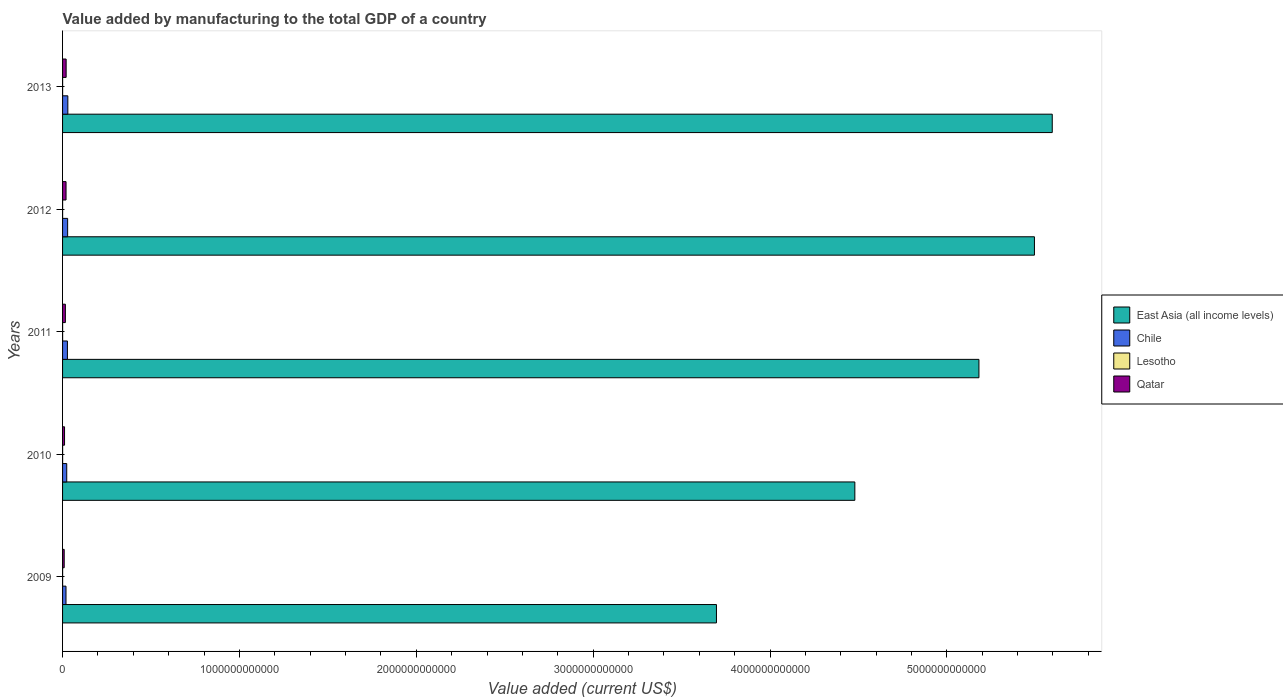How many different coloured bars are there?
Provide a succinct answer. 4. How many groups of bars are there?
Provide a short and direct response. 5. Are the number of bars per tick equal to the number of legend labels?
Your response must be concise. Yes. How many bars are there on the 4th tick from the top?
Provide a succinct answer. 4. What is the label of the 2nd group of bars from the top?
Give a very brief answer. 2012. What is the value added by manufacturing to the total GDP in East Asia (all income levels) in 2012?
Keep it short and to the point. 5.50e+12. Across all years, what is the maximum value added by manufacturing to the total GDP in Chile?
Your answer should be compact. 2.98e+1. Across all years, what is the minimum value added by manufacturing to the total GDP in Qatar?
Offer a very short reply. 9.22e+09. In which year was the value added by manufacturing to the total GDP in Qatar maximum?
Your answer should be compact. 2013. What is the total value added by manufacturing to the total GDP in Qatar in the graph?
Ensure brevity in your answer.  7.62e+1. What is the difference between the value added by manufacturing to the total GDP in Lesotho in 2010 and that in 2013?
Your answer should be very brief. 7.15e+07. What is the difference between the value added by manufacturing to the total GDP in Qatar in 2013 and the value added by manufacturing to the total GDP in Chile in 2012?
Offer a very short reply. -8.42e+09. What is the average value added by manufacturing to the total GDP in East Asia (all income levels) per year?
Provide a short and direct response. 4.89e+12. In the year 2013, what is the difference between the value added by manufacturing to the total GDP in Lesotho and value added by manufacturing to the total GDP in East Asia (all income levels)?
Your answer should be very brief. -5.60e+12. In how many years, is the value added by manufacturing to the total GDP in Qatar greater than 3800000000000 US$?
Provide a short and direct response. 0. What is the ratio of the value added by manufacturing to the total GDP in Qatar in 2009 to that in 2011?
Offer a terse response. 0.58. Is the value added by manufacturing to the total GDP in Chile in 2009 less than that in 2010?
Offer a very short reply. Yes. Is the difference between the value added by manufacturing to the total GDP in Lesotho in 2012 and 2013 greater than the difference between the value added by manufacturing to the total GDP in East Asia (all income levels) in 2012 and 2013?
Make the answer very short. Yes. What is the difference between the highest and the second highest value added by manufacturing to the total GDP in East Asia (all income levels)?
Keep it short and to the point. 1.01e+11. What is the difference between the highest and the lowest value added by manufacturing to the total GDP in Qatar?
Your answer should be compact. 1.10e+1. Is the sum of the value added by manufacturing to the total GDP in Chile in 2010 and 2013 greater than the maximum value added by manufacturing to the total GDP in East Asia (all income levels) across all years?
Your answer should be compact. No. What does the 1st bar from the top in 2011 represents?
Provide a succinct answer. Qatar. Is it the case that in every year, the sum of the value added by manufacturing to the total GDP in East Asia (all income levels) and value added by manufacturing to the total GDP in Lesotho is greater than the value added by manufacturing to the total GDP in Chile?
Provide a succinct answer. Yes. How many bars are there?
Your response must be concise. 20. How many years are there in the graph?
Provide a succinct answer. 5. What is the difference between two consecutive major ticks on the X-axis?
Offer a very short reply. 1.00e+12. Does the graph contain any zero values?
Make the answer very short. No. Where does the legend appear in the graph?
Your answer should be very brief. Center right. How many legend labels are there?
Your response must be concise. 4. How are the legend labels stacked?
Your answer should be very brief. Vertical. What is the title of the graph?
Your answer should be very brief. Value added by manufacturing to the total GDP of a country. Does "Greece" appear as one of the legend labels in the graph?
Offer a very short reply. No. What is the label or title of the X-axis?
Your answer should be compact. Value added (current US$). What is the label or title of the Y-axis?
Your answer should be compact. Years. What is the Value added (current US$) of East Asia (all income levels) in 2009?
Ensure brevity in your answer.  3.70e+12. What is the Value added (current US$) of Chile in 2009?
Your answer should be compact. 1.94e+1. What is the Value added (current US$) of Lesotho in 2009?
Provide a short and direct response. 2.50e+08. What is the Value added (current US$) in Qatar in 2009?
Your answer should be compact. 9.22e+09. What is the Value added (current US$) in East Asia (all income levels) in 2010?
Give a very brief answer. 4.48e+12. What is the Value added (current US$) of Chile in 2010?
Your response must be concise. 2.35e+1. What is the Value added (current US$) in Lesotho in 2010?
Keep it short and to the point. 2.76e+08. What is the Value added (current US$) of Qatar in 2010?
Offer a terse response. 1.12e+1. What is the Value added (current US$) in East Asia (all income levels) in 2011?
Keep it short and to the point. 5.18e+12. What is the Value added (current US$) in Chile in 2011?
Ensure brevity in your answer.  2.75e+1. What is the Value added (current US$) in Lesotho in 2011?
Your answer should be very brief. 2.64e+08. What is the Value added (current US$) of Qatar in 2011?
Make the answer very short. 1.59e+1. What is the Value added (current US$) of East Asia (all income levels) in 2012?
Give a very brief answer. 5.50e+12. What is the Value added (current US$) in Chile in 2012?
Make the answer very short. 2.87e+1. What is the Value added (current US$) in Lesotho in 2012?
Your answer should be compact. 2.41e+08. What is the Value added (current US$) in Qatar in 2012?
Provide a succinct answer. 1.97e+1. What is the Value added (current US$) of East Asia (all income levels) in 2013?
Keep it short and to the point. 5.60e+12. What is the Value added (current US$) of Chile in 2013?
Offer a terse response. 2.98e+1. What is the Value added (current US$) of Lesotho in 2013?
Offer a very short reply. 2.04e+08. What is the Value added (current US$) of Qatar in 2013?
Provide a short and direct response. 2.02e+1. Across all years, what is the maximum Value added (current US$) of East Asia (all income levels)?
Make the answer very short. 5.60e+12. Across all years, what is the maximum Value added (current US$) of Chile?
Your answer should be compact. 2.98e+1. Across all years, what is the maximum Value added (current US$) in Lesotho?
Give a very brief answer. 2.76e+08. Across all years, what is the maximum Value added (current US$) in Qatar?
Your answer should be very brief. 2.02e+1. Across all years, what is the minimum Value added (current US$) of East Asia (all income levels)?
Your answer should be compact. 3.70e+12. Across all years, what is the minimum Value added (current US$) of Chile?
Offer a terse response. 1.94e+1. Across all years, what is the minimum Value added (current US$) in Lesotho?
Provide a succinct answer. 2.04e+08. Across all years, what is the minimum Value added (current US$) in Qatar?
Your answer should be compact. 9.22e+09. What is the total Value added (current US$) of East Asia (all income levels) in the graph?
Provide a short and direct response. 2.44e+13. What is the total Value added (current US$) in Chile in the graph?
Offer a very short reply. 1.29e+11. What is the total Value added (current US$) in Lesotho in the graph?
Make the answer very short. 1.24e+09. What is the total Value added (current US$) in Qatar in the graph?
Keep it short and to the point. 7.62e+1. What is the difference between the Value added (current US$) in East Asia (all income levels) in 2009 and that in 2010?
Your answer should be very brief. -7.83e+11. What is the difference between the Value added (current US$) in Chile in 2009 and that in 2010?
Offer a very short reply. -4.11e+09. What is the difference between the Value added (current US$) in Lesotho in 2009 and that in 2010?
Your answer should be very brief. -2.59e+07. What is the difference between the Value added (current US$) of Qatar in 2009 and that in 2010?
Ensure brevity in your answer.  -2.00e+09. What is the difference between the Value added (current US$) of East Asia (all income levels) in 2009 and that in 2011?
Keep it short and to the point. -1.48e+12. What is the difference between the Value added (current US$) in Chile in 2009 and that in 2011?
Provide a succinct answer. -8.07e+09. What is the difference between the Value added (current US$) in Lesotho in 2009 and that in 2011?
Give a very brief answer. -1.40e+07. What is the difference between the Value added (current US$) in Qatar in 2009 and that in 2011?
Ensure brevity in your answer.  -6.66e+09. What is the difference between the Value added (current US$) in East Asia (all income levels) in 2009 and that in 2012?
Provide a short and direct response. -1.80e+12. What is the difference between the Value added (current US$) of Chile in 2009 and that in 2012?
Provide a succinct answer. -9.24e+09. What is the difference between the Value added (current US$) of Lesotho in 2009 and that in 2012?
Ensure brevity in your answer.  8.54e+06. What is the difference between the Value added (current US$) of Qatar in 2009 and that in 2012?
Offer a very short reply. -1.04e+1. What is the difference between the Value added (current US$) of East Asia (all income levels) in 2009 and that in 2013?
Your response must be concise. -1.90e+12. What is the difference between the Value added (current US$) in Chile in 2009 and that in 2013?
Ensure brevity in your answer.  -1.04e+1. What is the difference between the Value added (current US$) of Lesotho in 2009 and that in 2013?
Ensure brevity in your answer.  4.56e+07. What is the difference between the Value added (current US$) of Qatar in 2009 and that in 2013?
Your response must be concise. -1.10e+1. What is the difference between the Value added (current US$) in East Asia (all income levels) in 2010 and that in 2011?
Give a very brief answer. -7.02e+11. What is the difference between the Value added (current US$) in Chile in 2010 and that in 2011?
Offer a terse response. -3.96e+09. What is the difference between the Value added (current US$) of Lesotho in 2010 and that in 2011?
Keep it short and to the point. 1.19e+07. What is the difference between the Value added (current US$) in Qatar in 2010 and that in 2011?
Ensure brevity in your answer.  -4.66e+09. What is the difference between the Value added (current US$) of East Asia (all income levels) in 2010 and that in 2012?
Ensure brevity in your answer.  -1.02e+12. What is the difference between the Value added (current US$) of Chile in 2010 and that in 2012?
Offer a terse response. -5.13e+09. What is the difference between the Value added (current US$) in Lesotho in 2010 and that in 2012?
Your answer should be very brief. 3.45e+07. What is the difference between the Value added (current US$) of Qatar in 2010 and that in 2012?
Make the answer very short. -8.44e+09. What is the difference between the Value added (current US$) in East Asia (all income levels) in 2010 and that in 2013?
Make the answer very short. -1.12e+12. What is the difference between the Value added (current US$) of Chile in 2010 and that in 2013?
Your response must be concise. -6.30e+09. What is the difference between the Value added (current US$) of Lesotho in 2010 and that in 2013?
Your answer should be very brief. 7.15e+07. What is the difference between the Value added (current US$) of Qatar in 2010 and that in 2013?
Your response must be concise. -9.02e+09. What is the difference between the Value added (current US$) in East Asia (all income levels) in 2011 and that in 2012?
Provide a succinct answer. -3.14e+11. What is the difference between the Value added (current US$) of Chile in 2011 and that in 2012?
Provide a succinct answer. -1.17e+09. What is the difference between the Value added (current US$) of Lesotho in 2011 and that in 2012?
Keep it short and to the point. 2.26e+07. What is the difference between the Value added (current US$) in Qatar in 2011 and that in 2012?
Ensure brevity in your answer.  -3.77e+09. What is the difference between the Value added (current US$) in East Asia (all income levels) in 2011 and that in 2013?
Provide a short and direct response. -4.15e+11. What is the difference between the Value added (current US$) in Chile in 2011 and that in 2013?
Provide a succinct answer. -2.34e+09. What is the difference between the Value added (current US$) of Lesotho in 2011 and that in 2013?
Offer a terse response. 5.96e+07. What is the difference between the Value added (current US$) in Qatar in 2011 and that in 2013?
Make the answer very short. -4.35e+09. What is the difference between the Value added (current US$) in East Asia (all income levels) in 2012 and that in 2013?
Your answer should be very brief. -1.01e+11. What is the difference between the Value added (current US$) in Chile in 2012 and that in 2013?
Make the answer very short. -1.18e+09. What is the difference between the Value added (current US$) of Lesotho in 2012 and that in 2013?
Ensure brevity in your answer.  3.70e+07. What is the difference between the Value added (current US$) in Qatar in 2012 and that in 2013?
Your answer should be compact. -5.79e+08. What is the difference between the Value added (current US$) of East Asia (all income levels) in 2009 and the Value added (current US$) of Chile in 2010?
Provide a succinct answer. 3.67e+12. What is the difference between the Value added (current US$) of East Asia (all income levels) in 2009 and the Value added (current US$) of Lesotho in 2010?
Provide a short and direct response. 3.70e+12. What is the difference between the Value added (current US$) in East Asia (all income levels) in 2009 and the Value added (current US$) in Qatar in 2010?
Keep it short and to the point. 3.69e+12. What is the difference between the Value added (current US$) of Chile in 2009 and the Value added (current US$) of Lesotho in 2010?
Your response must be concise. 1.91e+1. What is the difference between the Value added (current US$) of Chile in 2009 and the Value added (current US$) of Qatar in 2010?
Your response must be concise. 8.20e+09. What is the difference between the Value added (current US$) in Lesotho in 2009 and the Value added (current US$) in Qatar in 2010?
Offer a terse response. -1.10e+1. What is the difference between the Value added (current US$) in East Asia (all income levels) in 2009 and the Value added (current US$) in Chile in 2011?
Give a very brief answer. 3.67e+12. What is the difference between the Value added (current US$) in East Asia (all income levels) in 2009 and the Value added (current US$) in Lesotho in 2011?
Keep it short and to the point. 3.70e+12. What is the difference between the Value added (current US$) of East Asia (all income levels) in 2009 and the Value added (current US$) of Qatar in 2011?
Make the answer very short. 3.68e+12. What is the difference between the Value added (current US$) of Chile in 2009 and the Value added (current US$) of Lesotho in 2011?
Offer a terse response. 1.92e+1. What is the difference between the Value added (current US$) of Chile in 2009 and the Value added (current US$) of Qatar in 2011?
Your response must be concise. 3.54e+09. What is the difference between the Value added (current US$) of Lesotho in 2009 and the Value added (current US$) of Qatar in 2011?
Make the answer very short. -1.56e+1. What is the difference between the Value added (current US$) in East Asia (all income levels) in 2009 and the Value added (current US$) in Chile in 2012?
Offer a very short reply. 3.67e+12. What is the difference between the Value added (current US$) of East Asia (all income levels) in 2009 and the Value added (current US$) of Lesotho in 2012?
Offer a very short reply. 3.70e+12. What is the difference between the Value added (current US$) of East Asia (all income levels) in 2009 and the Value added (current US$) of Qatar in 2012?
Offer a terse response. 3.68e+12. What is the difference between the Value added (current US$) in Chile in 2009 and the Value added (current US$) in Lesotho in 2012?
Ensure brevity in your answer.  1.92e+1. What is the difference between the Value added (current US$) in Chile in 2009 and the Value added (current US$) in Qatar in 2012?
Give a very brief answer. -2.33e+08. What is the difference between the Value added (current US$) in Lesotho in 2009 and the Value added (current US$) in Qatar in 2012?
Ensure brevity in your answer.  -1.94e+1. What is the difference between the Value added (current US$) of East Asia (all income levels) in 2009 and the Value added (current US$) of Chile in 2013?
Provide a succinct answer. 3.67e+12. What is the difference between the Value added (current US$) of East Asia (all income levels) in 2009 and the Value added (current US$) of Lesotho in 2013?
Give a very brief answer. 3.70e+12. What is the difference between the Value added (current US$) of East Asia (all income levels) in 2009 and the Value added (current US$) of Qatar in 2013?
Give a very brief answer. 3.68e+12. What is the difference between the Value added (current US$) in Chile in 2009 and the Value added (current US$) in Lesotho in 2013?
Make the answer very short. 1.92e+1. What is the difference between the Value added (current US$) of Chile in 2009 and the Value added (current US$) of Qatar in 2013?
Give a very brief answer. -8.12e+08. What is the difference between the Value added (current US$) in Lesotho in 2009 and the Value added (current US$) in Qatar in 2013?
Your answer should be compact. -2.00e+1. What is the difference between the Value added (current US$) in East Asia (all income levels) in 2010 and the Value added (current US$) in Chile in 2011?
Give a very brief answer. 4.45e+12. What is the difference between the Value added (current US$) in East Asia (all income levels) in 2010 and the Value added (current US$) in Lesotho in 2011?
Give a very brief answer. 4.48e+12. What is the difference between the Value added (current US$) of East Asia (all income levels) in 2010 and the Value added (current US$) of Qatar in 2011?
Provide a short and direct response. 4.46e+12. What is the difference between the Value added (current US$) of Chile in 2010 and the Value added (current US$) of Lesotho in 2011?
Provide a succinct answer. 2.33e+1. What is the difference between the Value added (current US$) of Chile in 2010 and the Value added (current US$) of Qatar in 2011?
Keep it short and to the point. 7.65e+09. What is the difference between the Value added (current US$) in Lesotho in 2010 and the Value added (current US$) in Qatar in 2011?
Offer a terse response. -1.56e+1. What is the difference between the Value added (current US$) in East Asia (all income levels) in 2010 and the Value added (current US$) in Chile in 2012?
Offer a very short reply. 4.45e+12. What is the difference between the Value added (current US$) in East Asia (all income levels) in 2010 and the Value added (current US$) in Lesotho in 2012?
Keep it short and to the point. 4.48e+12. What is the difference between the Value added (current US$) of East Asia (all income levels) in 2010 and the Value added (current US$) of Qatar in 2012?
Keep it short and to the point. 4.46e+12. What is the difference between the Value added (current US$) of Chile in 2010 and the Value added (current US$) of Lesotho in 2012?
Ensure brevity in your answer.  2.33e+1. What is the difference between the Value added (current US$) in Chile in 2010 and the Value added (current US$) in Qatar in 2012?
Provide a short and direct response. 3.87e+09. What is the difference between the Value added (current US$) in Lesotho in 2010 and the Value added (current US$) in Qatar in 2012?
Your response must be concise. -1.94e+1. What is the difference between the Value added (current US$) in East Asia (all income levels) in 2010 and the Value added (current US$) in Chile in 2013?
Ensure brevity in your answer.  4.45e+12. What is the difference between the Value added (current US$) of East Asia (all income levels) in 2010 and the Value added (current US$) of Lesotho in 2013?
Keep it short and to the point. 4.48e+12. What is the difference between the Value added (current US$) in East Asia (all income levels) in 2010 and the Value added (current US$) in Qatar in 2013?
Your answer should be very brief. 4.46e+12. What is the difference between the Value added (current US$) of Chile in 2010 and the Value added (current US$) of Lesotho in 2013?
Make the answer very short. 2.33e+1. What is the difference between the Value added (current US$) in Chile in 2010 and the Value added (current US$) in Qatar in 2013?
Provide a short and direct response. 3.30e+09. What is the difference between the Value added (current US$) in Lesotho in 2010 and the Value added (current US$) in Qatar in 2013?
Give a very brief answer. -2.00e+1. What is the difference between the Value added (current US$) in East Asia (all income levels) in 2011 and the Value added (current US$) in Chile in 2012?
Offer a terse response. 5.15e+12. What is the difference between the Value added (current US$) in East Asia (all income levels) in 2011 and the Value added (current US$) in Lesotho in 2012?
Your answer should be compact. 5.18e+12. What is the difference between the Value added (current US$) in East Asia (all income levels) in 2011 and the Value added (current US$) in Qatar in 2012?
Keep it short and to the point. 5.16e+12. What is the difference between the Value added (current US$) in Chile in 2011 and the Value added (current US$) in Lesotho in 2012?
Provide a short and direct response. 2.72e+1. What is the difference between the Value added (current US$) of Chile in 2011 and the Value added (current US$) of Qatar in 2012?
Your response must be concise. 7.83e+09. What is the difference between the Value added (current US$) of Lesotho in 2011 and the Value added (current US$) of Qatar in 2012?
Keep it short and to the point. -1.94e+1. What is the difference between the Value added (current US$) of East Asia (all income levels) in 2011 and the Value added (current US$) of Chile in 2013?
Make the answer very short. 5.15e+12. What is the difference between the Value added (current US$) in East Asia (all income levels) in 2011 and the Value added (current US$) in Lesotho in 2013?
Provide a succinct answer. 5.18e+12. What is the difference between the Value added (current US$) in East Asia (all income levels) in 2011 and the Value added (current US$) in Qatar in 2013?
Give a very brief answer. 5.16e+12. What is the difference between the Value added (current US$) in Chile in 2011 and the Value added (current US$) in Lesotho in 2013?
Give a very brief answer. 2.73e+1. What is the difference between the Value added (current US$) of Chile in 2011 and the Value added (current US$) of Qatar in 2013?
Make the answer very short. 7.26e+09. What is the difference between the Value added (current US$) of Lesotho in 2011 and the Value added (current US$) of Qatar in 2013?
Your answer should be compact. -2.00e+1. What is the difference between the Value added (current US$) of East Asia (all income levels) in 2012 and the Value added (current US$) of Chile in 2013?
Provide a short and direct response. 5.47e+12. What is the difference between the Value added (current US$) of East Asia (all income levels) in 2012 and the Value added (current US$) of Lesotho in 2013?
Give a very brief answer. 5.49e+12. What is the difference between the Value added (current US$) of East Asia (all income levels) in 2012 and the Value added (current US$) of Qatar in 2013?
Ensure brevity in your answer.  5.47e+12. What is the difference between the Value added (current US$) in Chile in 2012 and the Value added (current US$) in Lesotho in 2013?
Your response must be concise. 2.85e+1. What is the difference between the Value added (current US$) in Chile in 2012 and the Value added (current US$) in Qatar in 2013?
Ensure brevity in your answer.  8.42e+09. What is the difference between the Value added (current US$) in Lesotho in 2012 and the Value added (current US$) in Qatar in 2013?
Your response must be concise. -2.00e+1. What is the average Value added (current US$) in East Asia (all income levels) per year?
Provide a short and direct response. 4.89e+12. What is the average Value added (current US$) of Chile per year?
Make the answer very short. 2.58e+1. What is the average Value added (current US$) in Lesotho per year?
Provide a succinct answer. 2.47e+08. What is the average Value added (current US$) of Qatar per year?
Your answer should be compact. 1.52e+1. In the year 2009, what is the difference between the Value added (current US$) in East Asia (all income levels) and Value added (current US$) in Chile?
Keep it short and to the point. 3.68e+12. In the year 2009, what is the difference between the Value added (current US$) of East Asia (all income levels) and Value added (current US$) of Lesotho?
Provide a succinct answer. 3.70e+12. In the year 2009, what is the difference between the Value added (current US$) of East Asia (all income levels) and Value added (current US$) of Qatar?
Give a very brief answer. 3.69e+12. In the year 2009, what is the difference between the Value added (current US$) of Chile and Value added (current US$) of Lesotho?
Offer a very short reply. 1.92e+1. In the year 2009, what is the difference between the Value added (current US$) in Chile and Value added (current US$) in Qatar?
Your answer should be compact. 1.02e+1. In the year 2009, what is the difference between the Value added (current US$) in Lesotho and Value added (current US$) in Qatar?
Provide a short and direct response. -8.97e+09. In the year 2010, what is the difference between the Value added (current US$) of East Asia (all income levels) and Value added (current US$) of Chile?
Make the answer very short. 4.46e+12. In the year 2010, what is the difference between the Value added (current US$) of East Asia (all income levels) and Value added (current US$) of Lesotho?
Keep it short and to the point. 4.48e+12. In the year 2010, what is the difference between the Value added (current US$) of East Asia (all income levels) and Value added (current US$) of Qatar?
Ensure brevity in your answer.  4.47e+12. In the year 2010, what is the difference between the Value added (current US$) of Chile and Value added (current US$) of Lesotho?
Your response must be concise. 2.33e+1. In the year 2010, what is the difference between the Value added (current US$) in Chile and Value added (current US$) in Qatar?
Your answer should be very brief. 1.23e+1. In the year 2010, what is the difference between the Value added (current US$) of Lesotho and Value added (current US$) of Qatar?
Your answer should be very brief. -1.09e+1. In the year 2011, what is the difference between the Value added (current US$) of East Asia (all income levels) and Value added (current US$) of Chile?
Provide a succinct answer. 5.15e+12. In the year 2011, what is the difference between the Value added (current US$) in East Asia (all income levels) and Value added (current US$) in Lesotho?
Offer a very short reply. 5.18e+12. In the year 2011, what is the difference between the Value added (current US$) in East Asia (all income levels) and Value added (current US$) in Qatar?
Your response must be concise. 5.17e+12. In the year 2011, what is the difference between the Value added (current US$) in Chile and Value added (current US$) in Lesotho?
Keep it short and to the point. 2.72e+1. In the year 2011, what is the difference between the Value added (current US$) in Chile and Value added (current US$) in Qatar?
Your answer should be very brief. 1.16e+1. In the year 2011, what is the difference between the Value added (current US$) in Lesotho and Value added (current US$) in Qatar?
Give a very brief answer. -1.56e+1. In the year 2012, what is the difference between the Value added (current US$) in East Asia (all income levels) and Value added (current US$) in Chile?
Your answer should be compact. 5.47e+12. In the year 2012, what is the difference between the Value added (current US$) in East Asia (all income levels) and Value added (current US$) in Lesotho?
Provide a succinct answer. 5.49e+12. In the year 2012, what is the difference between the Value added (current US$) of East Asia (all income levels) and Value added (current US$) of Qatar?
Give a very brief answer. 5.48e+12. In the year 2012, what is the difference between the Value added (current US$) in Chile and Value added (current US$) in Lesotho?
Keep it short and to the point. 2.84e+1. In the year 2012, what is the difference between the Value added (current US$) in Chile and Value added (current US$) in Qatar?
Your answer should be compact. 9.00e+09. In the year 2012, what is the difference between the Value added (current US$) in Lesotho and Value added (current US$) in Qatar?
Provide a short and direct response. -1.94e+1. In the year 2013, what is the difference between the Value added (current US$) in East Asia (all income levels) and Value added (current US$) in Chile?
Keep it short and to the point. 5.57e+12. In the year 2013, what is the difference between the Value added (current US$) of East Asia (all income levels) and Value added (current US$) of Lesotho?
Provide a succinct answer. 5.60e+12. In the year 2013, what is the difference between the Value added (current US$) in East Asia (all income levels) and Value added (current US$) in Qatar?
Your answer should be very brief. 5.58e+12. In the year 2013, what is the difference between the Value added (current US$) of Chile and Value added (current US$) of Lesotho?
Provide a succinct answer. 2.96e+1. In the year 2013, what is the difference between the Value added (current US$) in Chile and Value added (current US$) in Qatar?
Your answer should be very brief. 9.60e+09. In the year 2013, what is the difference between the Value added (current US$) in Lesotho and Value added (current US$) in Qatar?
Ensure brevity in your answer.  -2.00e+1. What is the ratio of the Value added (current US$) in East Asia (all income levels) in 2009 to that in 2010?
Your response must be concise. 0.83. What is the ratio of the Value added (current US$) in Chile in 2009 to that in 2010?
Provide a short and direct response. 0.83. What is the ratio of the Value added (current US$) of Lesotho in 2009 to that in 2010?
Offer a very short reply. 0.91. What is the ratio of the Value added (current US$) of Qatar in 2009 to that in 2010?
Your answer should be very brief. 0.82. What is the ratio of the Value added (current US$) in East Asia (all income levels) in 2009 to that in 2011?
Give a very brief answer. 0.71. What is the ratio of the Value added (current US$) of Chile in 2009 to that in 2011?
Provide a succinct answer. 0.71. What is the ratio of the Value added (current US$) of Lesotho in 2009 to that in 2011?
Keep it short and to the point. 0.95. What is the ratio of the Value added (current US$) of Qatar in 2009 to that in 2011?
Make the answer very short. 0.58. What is the ratio of the Value added (current US$) in East Asia (all income levels) in 2009 to that in 2012?
Give a very brief answer. 0.67. What is the ratio of the Value added (current US$) in Chile in 2009 to that in 2012?
Offer a terse response. 0.68. What is the ratio of the Value added (current US$) of Lesotho in 2009 to that in 2012?
Your answer should be very brief. 1.04. What is the ratio of the Value added (current US$) in Qatar in 2009 to that in 2012?
Provide a short and direct response. 0.47. What is the ratio of the Value added (current US$) in East Asia (all income levels) in 2009 to that in 2013?
Provide a short and direct response. 0.66. What is the ratio of the Value added (current US$) in Chile in 2009 to that in 2013?
Your answer should be very brief. 0.65. What is the ratio of the Value added (current US$) of Lesotho in 2009 to that in 2013?
Ensure brevity in your answer.  1.22. What is the ratio of the Value added (current US$) of Qatar in 2009 to that in 2013?
Provide a short and direct response. 0.46. What is the ratio of the Value added (current US$) in East Asia (all income levels) in 2010 to that in 2011?
Provide a short and direct response. 0.86. What is the ratio of the Value added (current US$) of Chile in 2010 to that in 2011?
Keep it short and to the point. 0.86. What is the ratio of the Value added (current US$) of Lesotho in 2010 to that in 2011?
Make the answer very short. 1.05. What is the ratio of the Value added (current US$) of Qatar in 2010 to that in 2011?
Make the answer very short. 0.71. What is the ratio of the Value added (current US$) of East Asia (all income levels) in 2010 to that in 2012?
Ensure brevity in your answer.  0.82. What is the ratio of the Value added (current US$) of Chile in 2010 to that in 2012?
Provide a short and direct response. 0.82. What is the ratio of the Value added (current US$) in Lesotho in 2010 to that in 2012?
Your response must be concise. 1.14. What is the ratio of the Value added (current US$) in Qatar in 2010 to that in 2012?
Provide a short and direct response. 0.57. What is the ratio of the Value added (current US$) in East Asia (all income levels) in 2010 to that in 2013?
Your answer should be very brief. 0.8. What is the ratio of the Value added (current US$) in Chile in 2010 to that in 2013?
Keep it short and to the point. 0.79. What is the ratio of the Value added (current US$) in Lesotho in 2010 to that in 2013?
Provide a succinct answer. 1.35. What is the ratio of the Value added (current US$) of Qatar in 2010 to that in 2013?
Your answer should be very brief. 0.55. What is the ratio of the Value added (current US$) of East Asia (all income levels) in 2011 to that in 2012?
Give a very brief answer. 0.94. What is the ratio of the Value added (current US$) in Chile in 2011 to that in 2012?
Offer a terse response. 0.96. What is the ratio of the Value added (current US$) of Lesotho in 2011 to that in 2012?
Your response must be concise. 1.09. What is the ratio of the Value added (current US$) of Qatar in 2011 to that in 2012?
Provide a short and direct response. 0.81. What is the ratio of the Value added (current US$) of East Asia (all income levels) in 2011 to that in 2013?
Provide a succinct answer. 0.93. What is the ratio of the Value added (current US$) in Chile in 2011 to that in 2013?
Ensure brevity in your answer.  0.92. What is the ratio of the Value added (current US$) in Lesotho in 2011 to that in 2013?
Give a very brief answer. 1.29. What is the ratio of the Value added (current US$) of Qatar in 2011 to that in 2013?
Your response must be concise. 0.79. What is the ratio of the Value added (current US$) in East Asia (all income levels) in 2012 to that in 2013?
Your answer should be compact. 0.98. What is the ratio of the Value added (current US$) of Chile in 2012 to that in 2013?
Make the answer very short. 0.96. What is the ratio of the Value added (current US$) in Lesotho in 2012 to that in 2013?
Keep it short and to the point. 1.18. What is the ratio of the Value added (current US$) of Qatar in 2012 to that in 2013?
Ensure brevity in your answer.  0.97. What is the difference between the highest and the second highest Value added (current US$) of East Asia (all income levels)?
Provide a succinct answer. 1.01e+11. What is the difference between the highest and the second highest Value added (current US$) of Chile?
Provide a succinct answer. 1.18e+09. What is the difference between the highest and the second highest Value added (current US$) of Lesotho?
Your response must be concise. 1.19e+07. What is the difference between the highest and the second highest Value added (current US$) of Qatar?
Provide a short and direct response. 5.79e+08. What is the difference between the highest and the lowest Value added (current US$) of East Asia (all income levels)?
Provide a short and direct response. 1.90e+12. What is the difference between the highest and the lowest Value added (current US$) in Chile?
Provide a short and direct response. 1.04e+1. What is the difference between the highest and the lowest Value added (current US$) of Lesotho?
Your answer should be very brief. 7.15e+07. What is the difference between the highest and the lowest Value added (current US$) of Qatar?
Keep it short and to the point. 1.10e+1. 